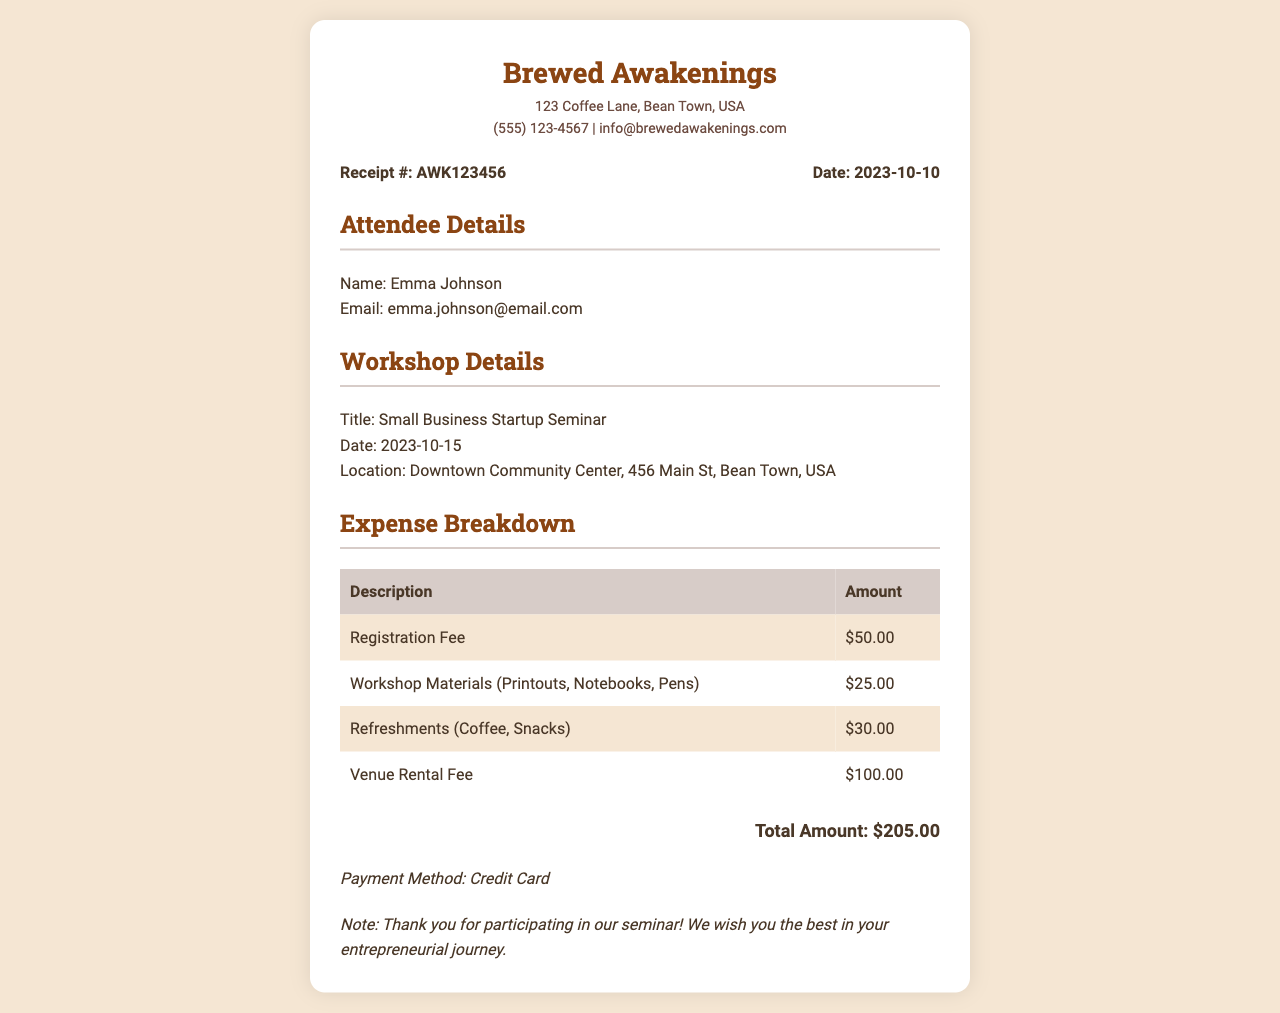What is the title of the workshop? The title of the workshop is clearly mentioned under the workshop details section.
Answer: Small Business Startup Seminar Who is the attendee? The name of the attendee is provided in the attendee details section.
Answer: Emma Johnson What is the total amount of expenses? The total amount is summarized at the bottom of the expense breakdown table.
Answer: $205.00 What payment method was used? The payment method is indicated clearly at the end of the receipt.
Answer: Credit Card What is the date of the workshop? The date of the workshop is listed under the workshop details section.
Answer: 2023-10-15 How much is the registration fee? The registration fee is specified in the expense breakdown table.
Answer: $50.00 Where is the venue located? The location of the venue is provided in the workshop details section.
Answer: Downtown Community Center, 456 Main St, Bean Town, USA What is the note at the bottom of the receipt? The note thanks the participant and wishes them well in their entrepreneurial journey, which is found below the payment method.
Answer: Thank you for participating in our seminar! We wish you the best in your entrepreneurial journey How many items are listed in the expense breakdown? The number of items can be counted from the expense breakdown table, including all the detailed costs.
Answer: 4 